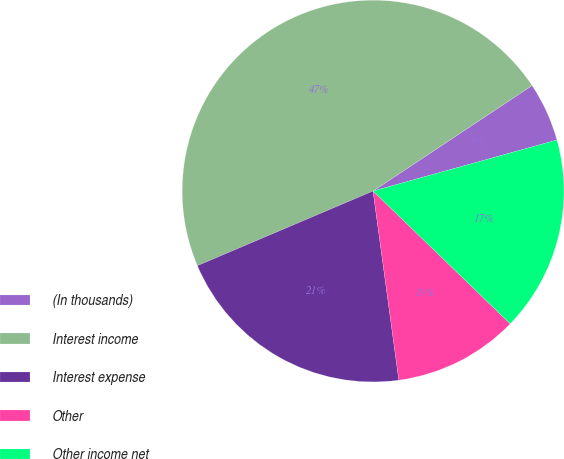Convert chart. <chart><loc_0><loc_0><loc_500><loc_500><pie_chart><fcel>(In thousands)<fcel>Interest income<fcel>Interest expense<fcel>Other<fcel>Other income net<nl><fcel>5.01%<fcel>47.07%<fcel>20.76%<fcel>10.6%<fcel>16.55%<nl></chart> 